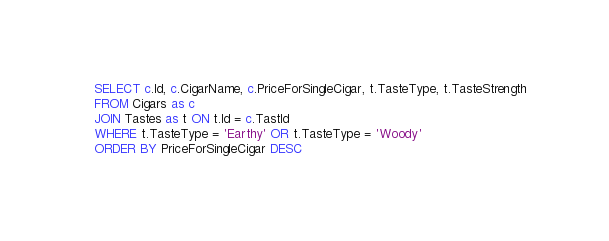<code> <loc_0><loc_0><loc_500><loc_500><_SQL_>SELECT c.Id, c.CigarName, c.PriceForSingleCigar, t.TasteType, t.TasteStrength
FROM Cigars as c
JOIN Tastes as t ON t.Id = c.TastId
WHERE t.TasteType = 'Earthy' OR t.TasteType = 'Woody'
ORDER BY PriceForSingleCigar DESC</code> 